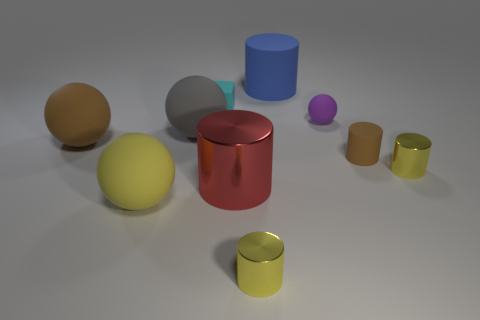Subtract 1 spheres. How many spheres are left? 3 Subtract all brown cylinders. How many cylinders are left? 4 Subtract all cyan cylinders. Subtract all cyan cubes. How many cylinders are left? 5 Subtract all balls. How many objects are left? 6 Subtract all small matte spheres. Subtract all large brown rubber things. How many objects are left? 8 Add 1 big brown matte things. How many big brown matte things are left? 2 Add 1 large brown rubber objects. How many large brown rubber objects exist? 2 Subtract 0 cyan cylinders. How many objects are left? 10 